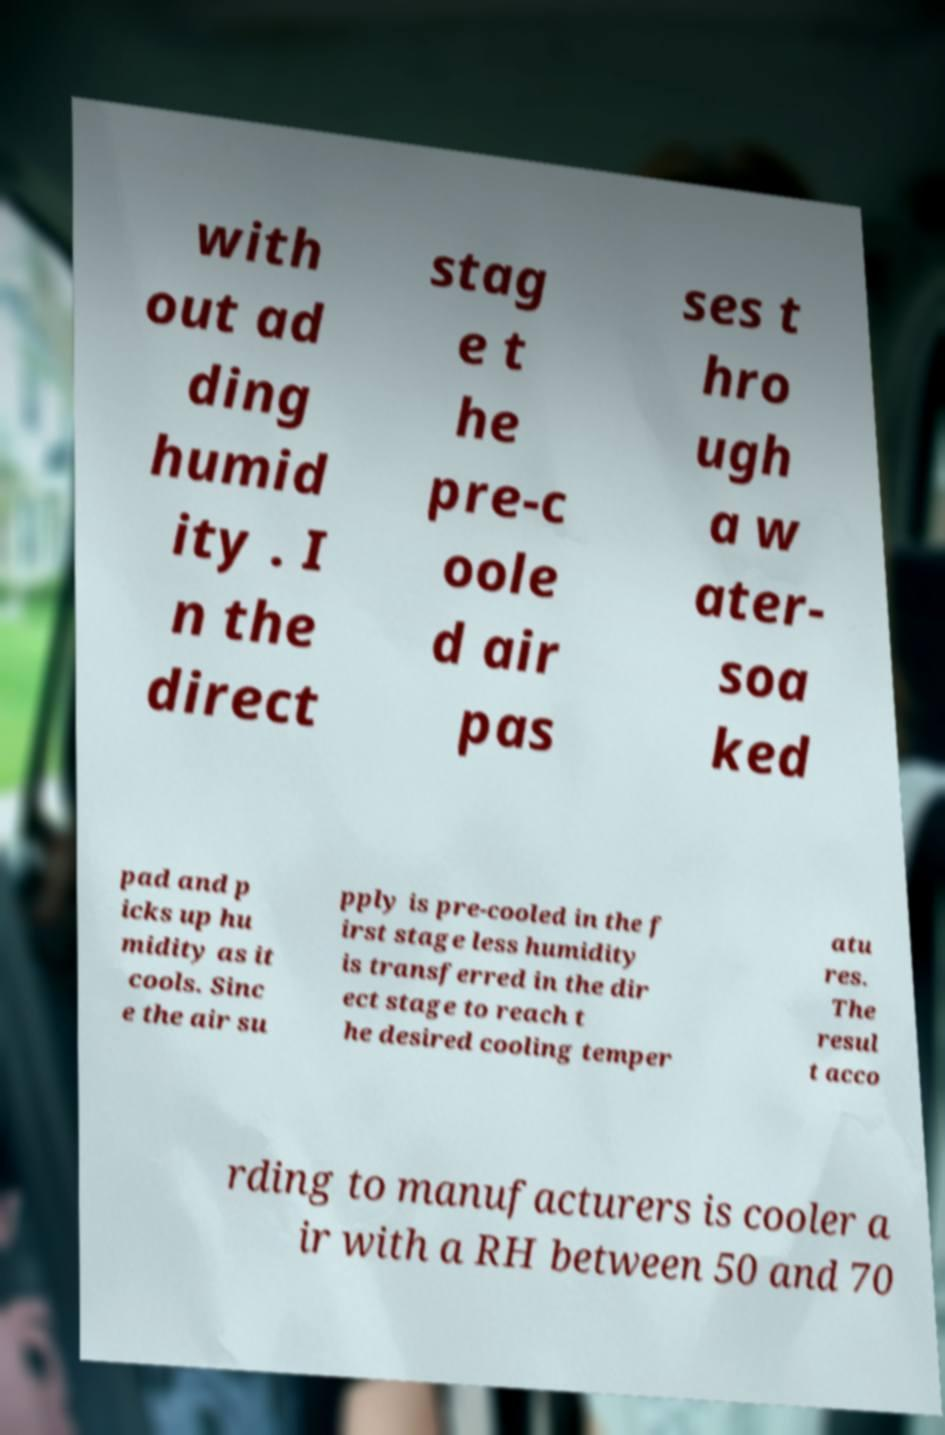For documentation purposes, I need the text within this image transcribed. Could you provide that? with out ad ding humid ity . I n the direct stag e t he pre-c oole d air pas ses t hro ugh a w ater- soa ked pad and p icks up hu midity as it cools. Sinc e the air su pply is pre-cooled in the f irst stage less humidity is transferred in the dir ect stage to reach t he desired cooling temper atu res. The resul t acco rding to manufacturers is cooler a ir with a RH between 50 and 70 